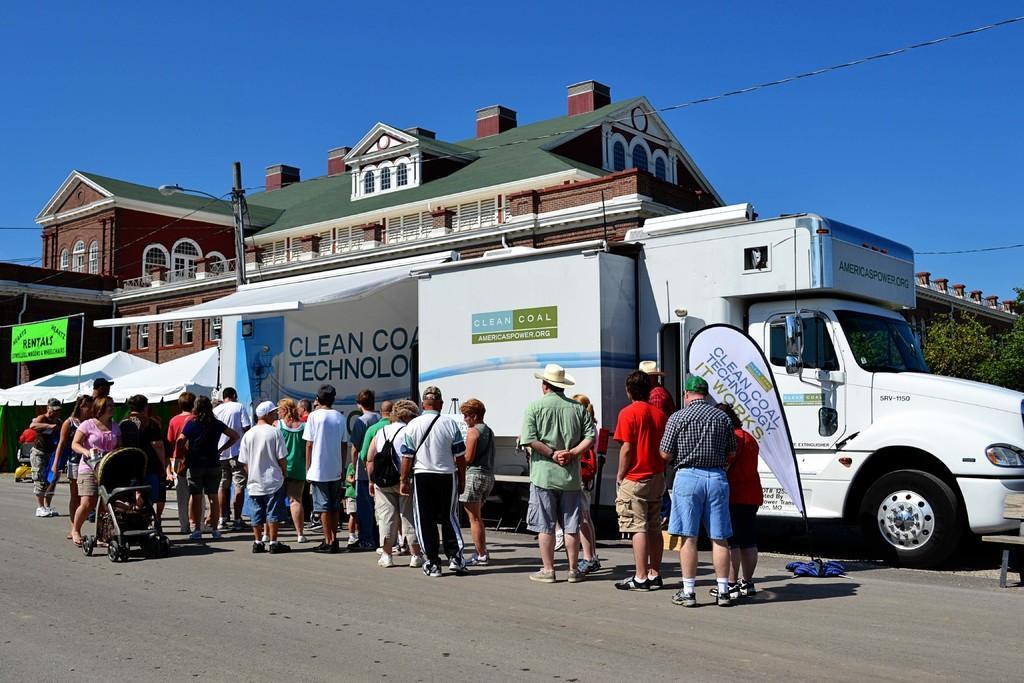Can you describe this image briefly? This picture is taken beside the road. On the road, there is a truck which is in white in color. Beside the truck there are people. Towards the left, there is a woman holding a baby vehicle, she is wearing a pink top. In the center, there is a man wearing a white t shirt, black trousers and carrying a bag. At the bottom, there is a road. On the top, there is a building with bricks, windows and roof tiles. In the background, there is a sky. 